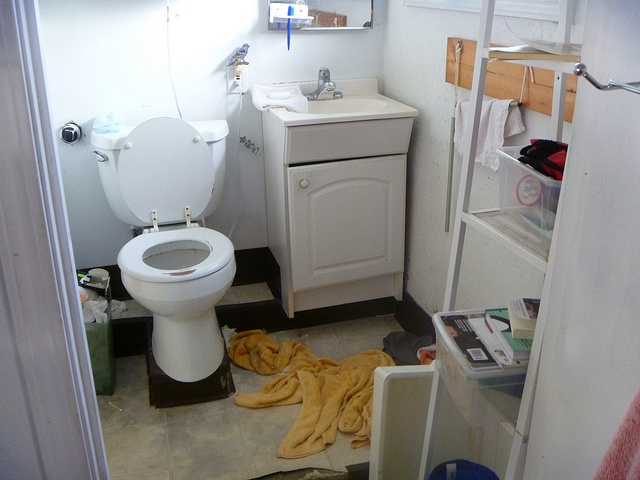Describe the objects in this image and their specific colors. I can see toilet in gray, lightgray, and darkgray tones, book in gray, black, and darkgray tones, book in gray, darkgray, and black tones, book in gray and black tones, and sink in gray, lightgray, and darkgray tones in this image. 